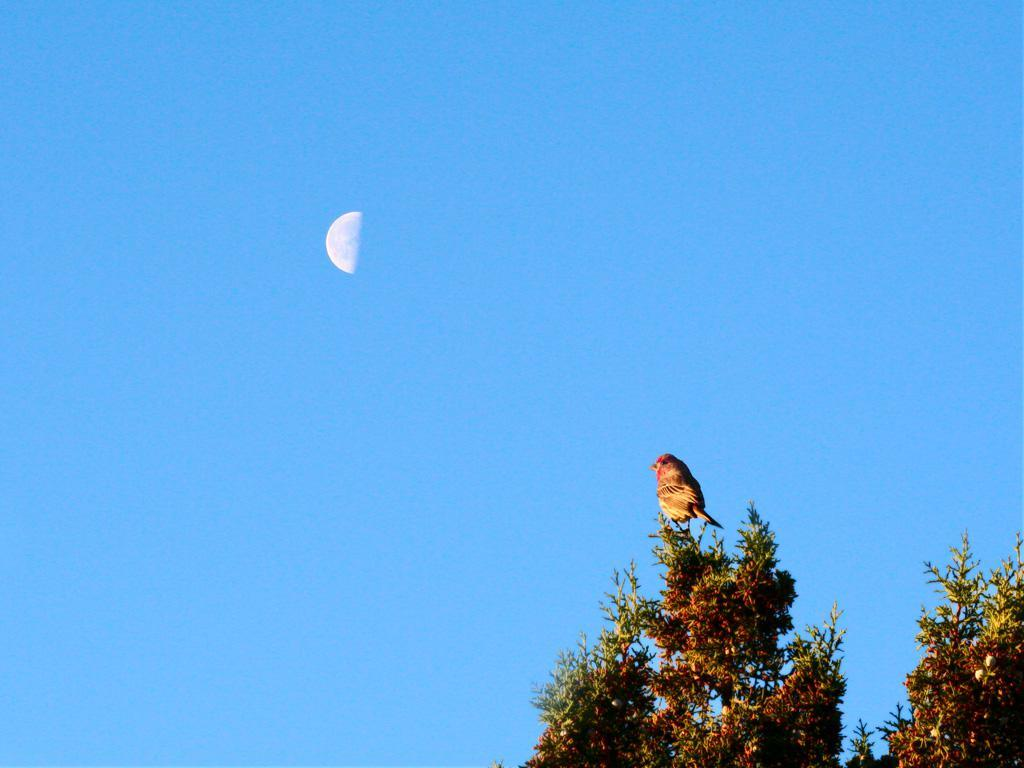What is located on the right side of the image? There is a tree on the right side of the image. What is sitting on the top of the tree? There is a bird sitting on the top of the tree. What can be seen in the sky in the image? The sky is visible in the image, and a half moon is visible in the sky. How would you describe the weather based on the image? The sky appears to be clear in the image, suggesting good weather. What type of force is being exerted on the tree by the sleet in the image? There is no sleet present in the image, so no force is being exerted on the tree by sleet. Is there an island visible in the image? No, there is no island present in the image. 